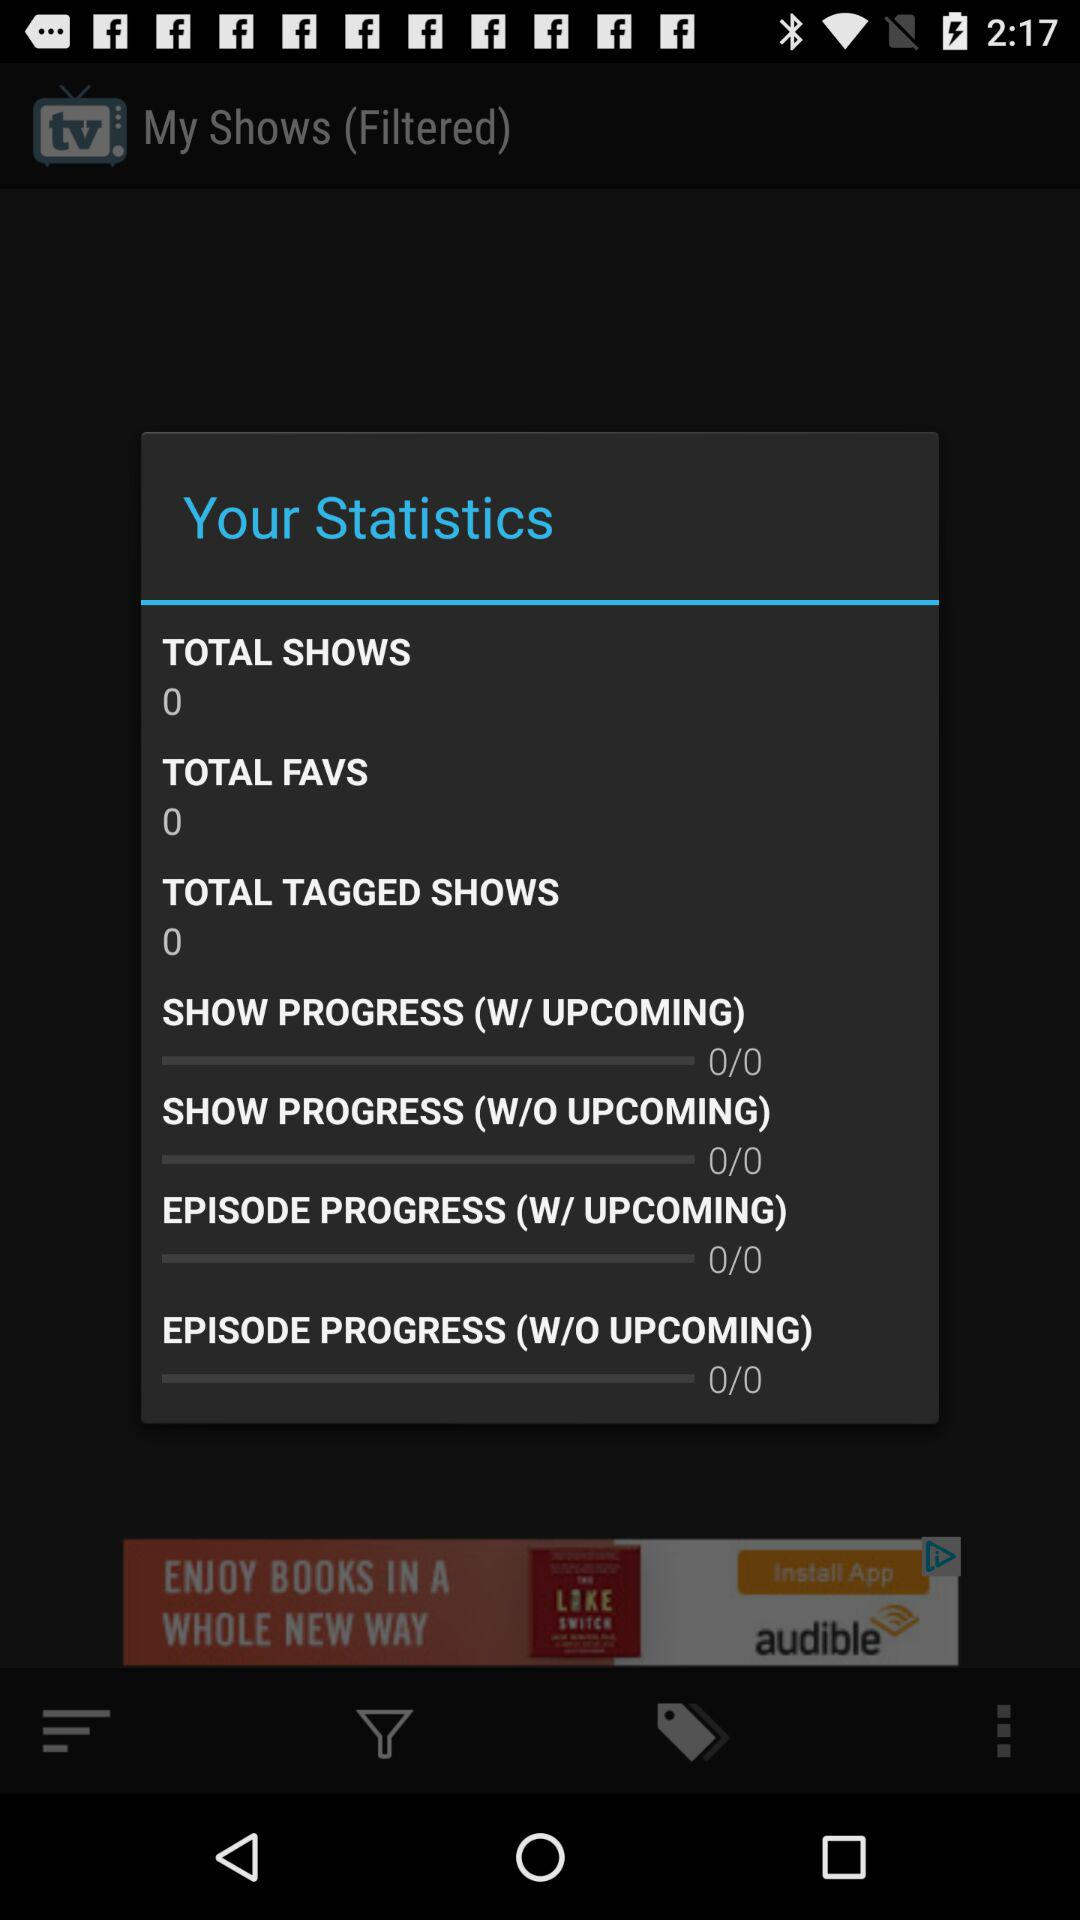How many more shows do I have tagged than marked as favorites?
Answer the question using a single word or phrase. 0 